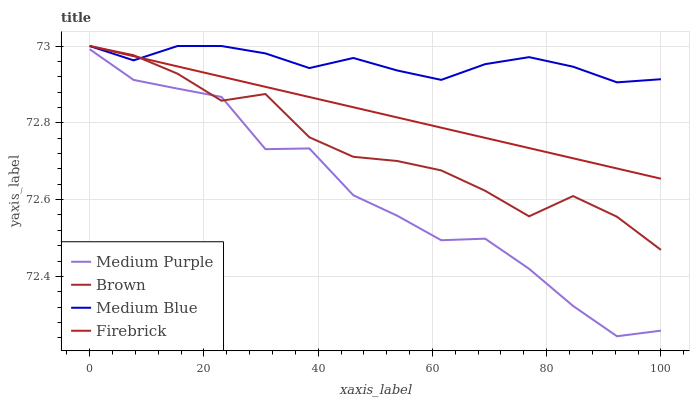Does Medium Purple have the minimum area under the curve?
Answer yes or no. Yes. Does Medium Blue have the maximum area under the curve?
Answer yes or no. Yes. Does Brown have the minimum area under the curve?
Answer yes or no. No. Does Brown have the maximum area under the curve?
Answer yes or no. No. Is Firebrick the smoothest?
Answer yes or no. Yes. Is Medium Purple the roughest?
Answer yes or no. Yes. Is Brown the smoothest?
Answer yes or no. No. Is Brown the roughest?
Answer yes or no. No. Does Medium Purple have the lowest value?
Answer yes or no. Yes. Does Brown have the lowest value?
Answer yes or no. No. Does Medium Blue have the highest value?
Answer yes or no. Yes. Is Medium Purple less than Firebrick?
Answer yes or no. Yes. Is Medium Blue greater than Medium Purple?
Answer yes or no. Yes. Does Firebrick intersect Medium Blue?
Answer yes or no. Yes. Is Firebrick less than Medium Blue?
Answer yes or no. No. Is Firebrick greater than Medium Blue?
Answer yes or no. No. Does Medium Purple intersect Firebrick?
Answer yes or no. No. 